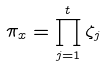Convert formula to latex. <formula><loc_0><loc_0><loc_500><loc_500>\pi _ { x } = \prod _ { j = 1 } ^ { t } \zeta _ { j }</formula> 